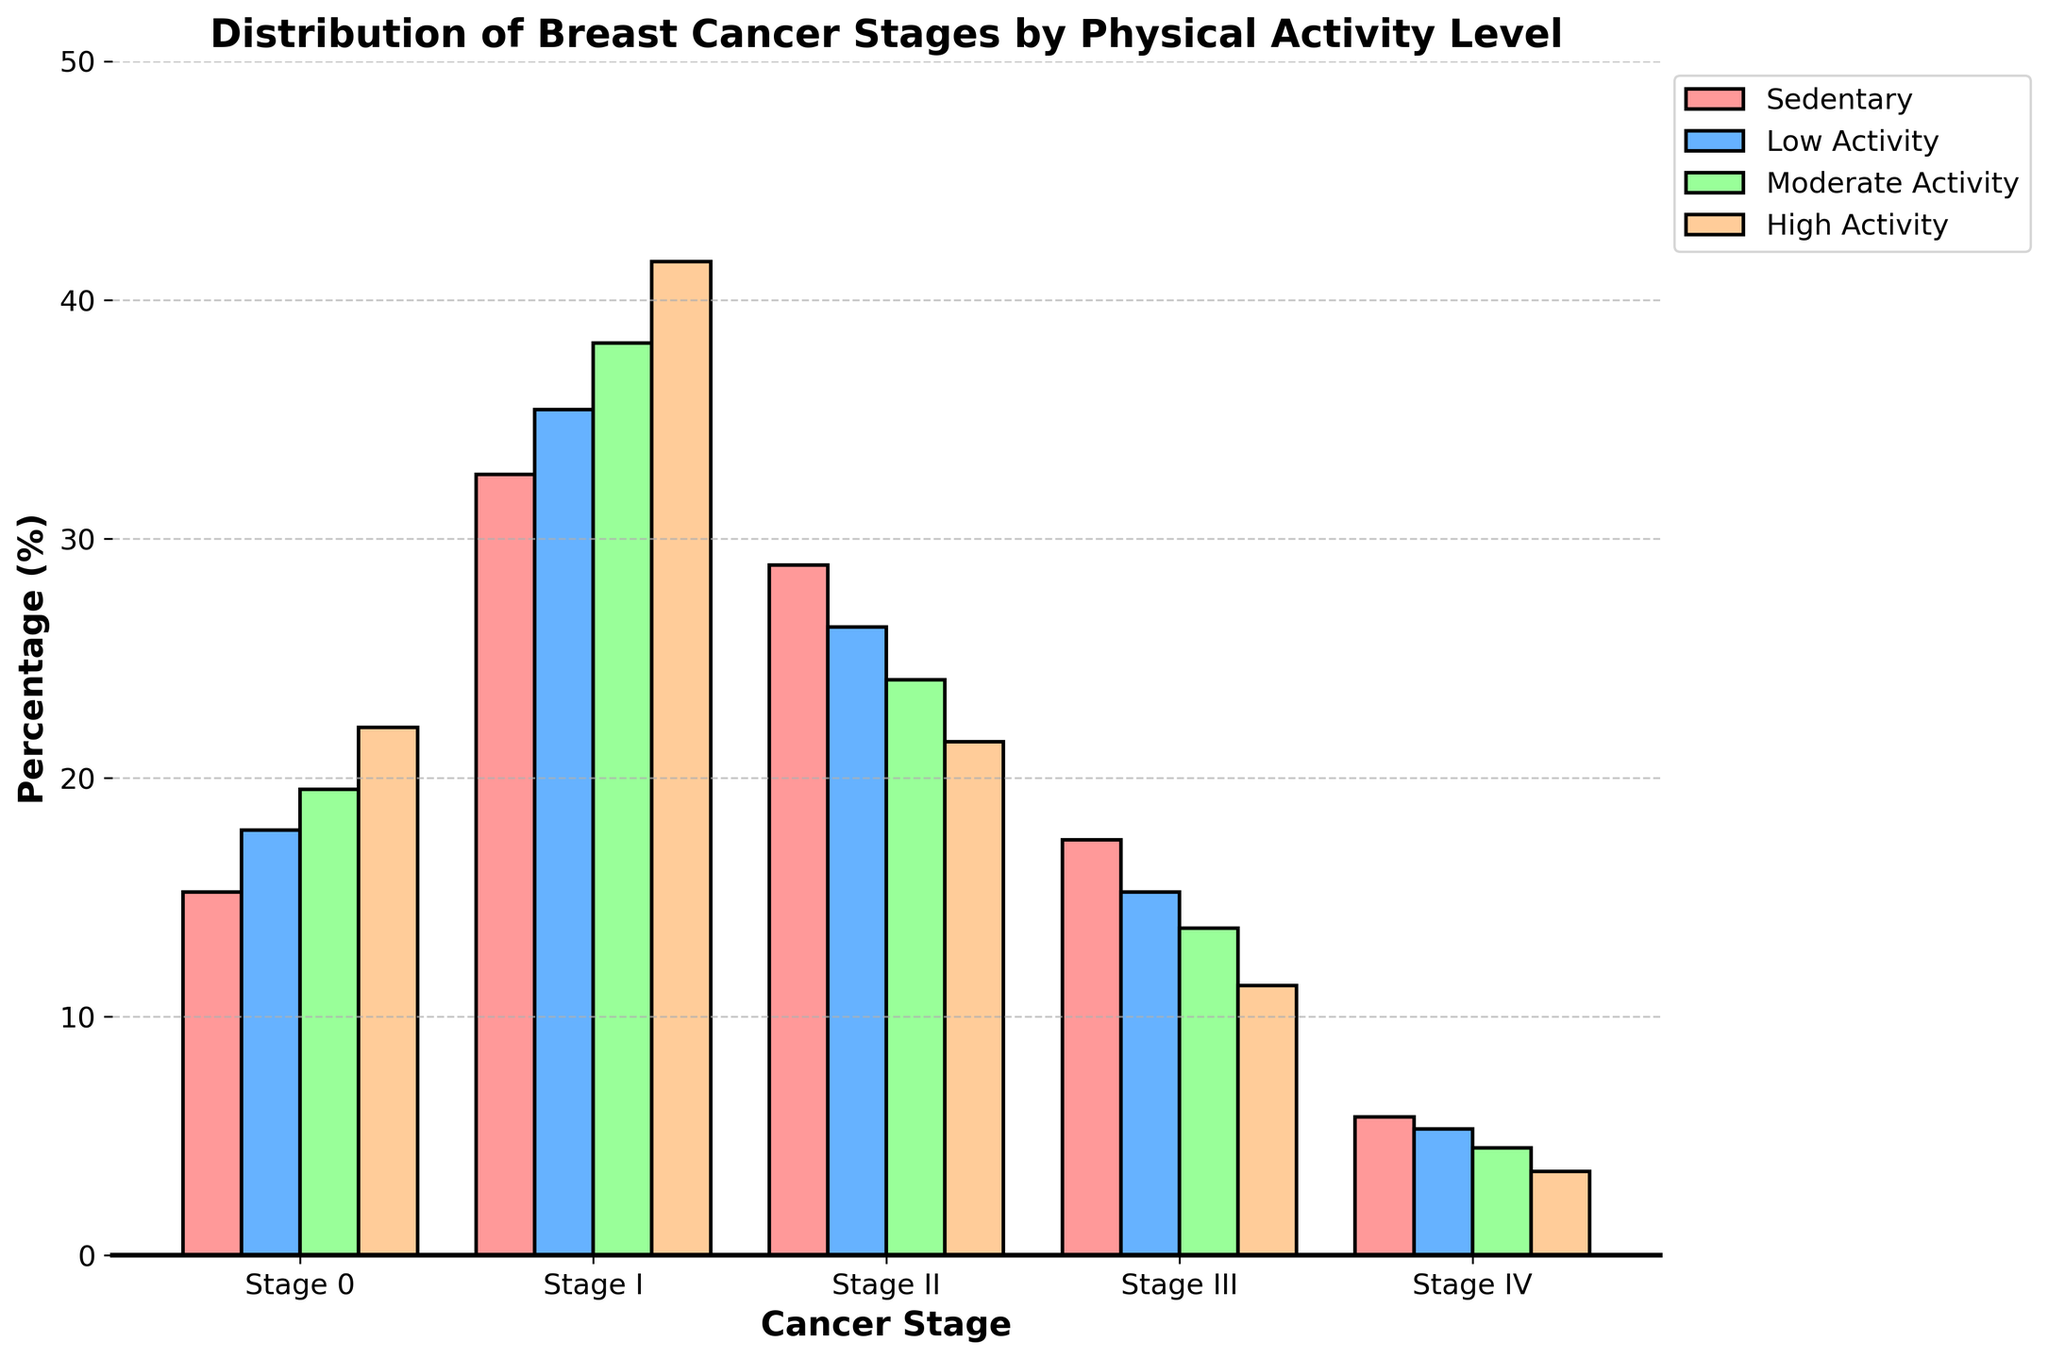What's the percentage of Stage I cancer for 'Moderate Activity' level? Locate the 'Stage I' row and find the percentage value under the 'Moderate Activity' column. It is 38.2%.
Answer: 38.2% Which physical activity level has the lowest percentage of Stage IV cancer? Compare all percentages in the 'Stage IV' row for each physical activity level, and identify the lowest value. It is 'High Activity' at 3.5%.
Answer: High Activity What is the percentage difference in Stage 0 cancer between 'Sedentary' and 'High Activity' levels? Find the percentage values in the 'Stage 0' row for 'Sedentary' and 'High Activity': 15.2% and 22.1% respectively. Subtract the smaller from the larger (22.1% - 15.2%).
Answer: 6.9% What is the total percentage of patients diagnosed with Stage I and Stage II cancer across all physical activity levels combined? Adding the percentages from the 'Stage I' and 'Stage II' rows across each physical activity level gives (32.7 + 35.4 + 38.2 + 41.6) + (28.9 + 26.3 + 24.1 + 21.5) = 147.9 + 100.8 = 248.7.
Answer: 248.7% Which physical activity level is associated with the highest percentage of Stage III cancer? Look at the 'Stage III' row and identify the highest percentage. It is 'Sedentary' at 17.4%.
Answer: Sedentary Does the percentage of Stage 0 cancer increase or decrease with physical activity level? Track the pattern in the 'Stage 0' row from 'Sedentary' to 'High Activity': 15.2, 17.8, 19.5, 22.1. The percentage consistently increases.
Answer: Increase How does the percentage of Stage IV cancer for 'Low Activity' compare to 'Moderate Activity'? Find the percentages for 'Stage IV' under 'Low Activity' and 'Moderate Activity': 5.3 and 4.5. 'Low Activity' has a higher percentage.
Answer: Low Activity is higher What is the average percentage of Stage II cancer among all physical activity levels? Add the Stage II percentage values across all activities and divide by the number of activities: (28.9 + 26.3 + 24.1 + 21.5) / 4 = 25.2%.
Answer: 25.2% Are there more Stage I or Stage III cancer cases for 'High Activity'? Compare the percentages for 'Stage I' and 'Stage III' under 'High Activity': 41.6% (Stage I) and 11.3% (Stage III). There are more Stage I cases.
Answer: Stage I What trend does the 'Stage IV' cancer percentage show as physical activity increases? Observe the 'Stage IV' row from 'Sedentary' to 'High Activity': 5.8, 5.3, 4.5, 3.5. The percentage consistently decreases.
Answer: Decreasing 